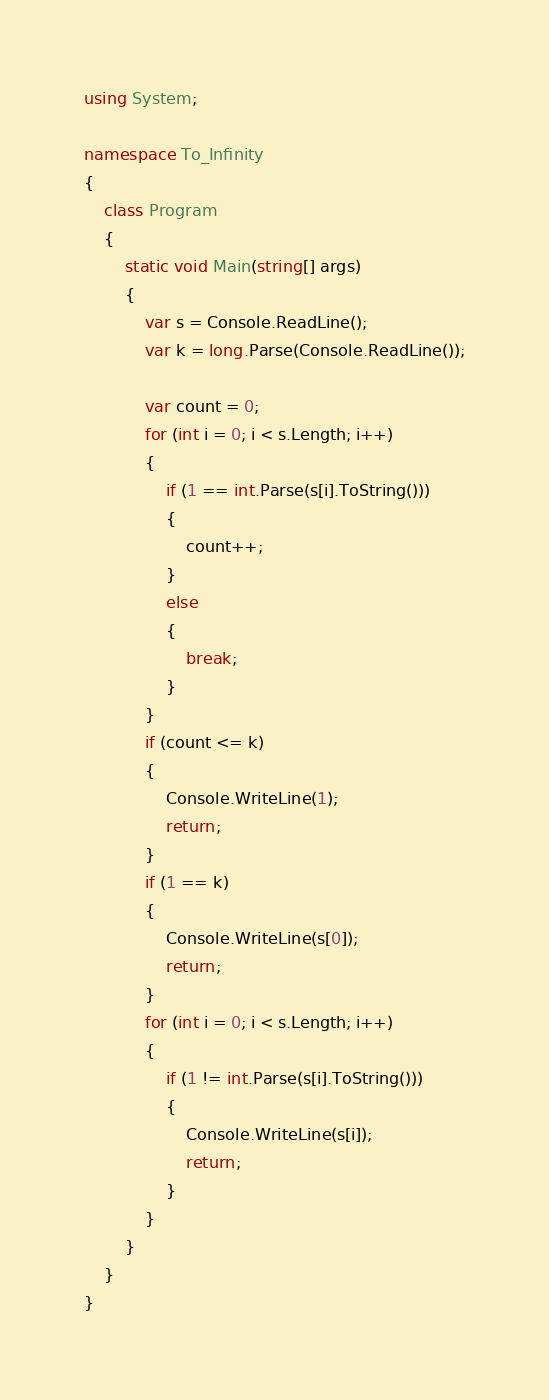Convert code to text. <code><loc_0><loc_0><loc_500><loc_500><_C#_>using System;

namespace To_Infinity
{
    class Program
    {
        static void Main(string[] args)
        {
            var s = Console.ReadLine();
            var k = long.Parse(Console.ReadLine());

            var count = 0;
            for (int i = 0; i < s.Length; i++)
            {
                if (1 == int.Parse(s[i].ToString()))
                {
                    count++;
                }
                else
                {
                    break;
                }
            }
            if (count <= k)
            {
                Console.WriteLine(1);
                return;
            }
            if (1 == k)
            {
                Console.WriteLine(s[0]);
                return;
            }
            for (int i = 0; i < s.Length; i++)
            {
                if (1 != int.Parse(s[i].ToString()))
                {
                    Console.WriteLine(s[i]);
                    return;
                }
            }
        }
    }
}
</code> 